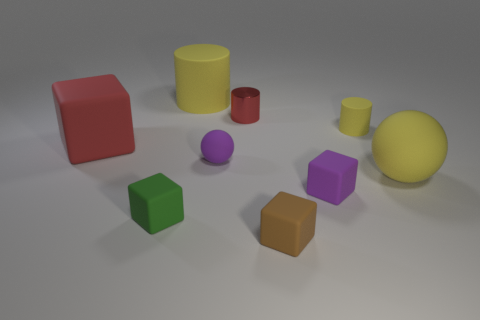What can you infer about the texture of the objects? The objects in the image seem to have a matte finish, with no significant reflections or glossiness, which suggests a non-metallic, possibly plastic or rubber-like texture. 